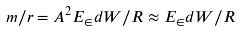<formula> <loc_0><loc_0><loc_500><loc_500>m / r = A ^ { 2 } E _ { \in } d { W } / R \approx E _ { \in } d { W } / R</formula> 